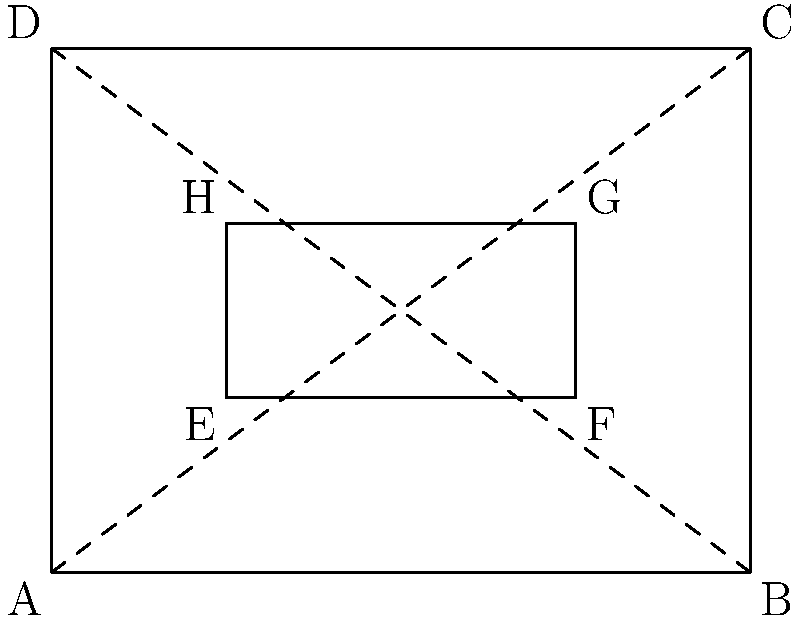In the diagram above representing a classic roast, what is the ratio of the area of the inner rectangle EFGH to the area of the outer rectangle ABCD? To find the ratio of the areas, we'll follow these steps:

1. Calculate the area of the outer rectangle ABCD:
   Width = 4 units, Height = 3 units
   Area_ABCD = 4 * 3 = 12 square units

2. Calculate the area of the inner rectangle EFGH:
   Width = 2 units (3 - 1), Height = 1 unit (2 - 1)
   Area_EFGH = 2 * 1 = 2 square units

3. Express the ratio of the areas:
   Ratio = Area_EFGH : Area_ABCD
         = 2 : 12
         = 1 : 6

4. Simplify the ratio:
   $$\frac{\text{Area}_\text{EFGH}}{\text{Area}_\text{ABCD}} = \frac{1}{6}$$

Therefore, the ratio of the area of the inner rectangle to the area of the outer rectangle is 1:6 or $\frac{1}{6}$.
Answer: $\frac{1}{6}$ 